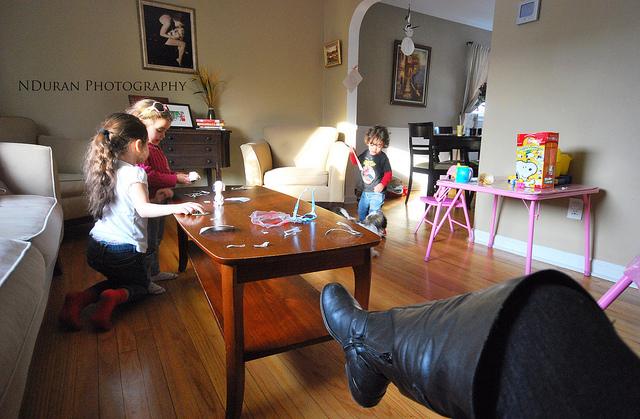How many people in the image are adult?
Be succinct. 1. What are the children playing with?
Write a very short answer. Toys. How does playing increase child development?
Keep it brief. Develops imagination. 